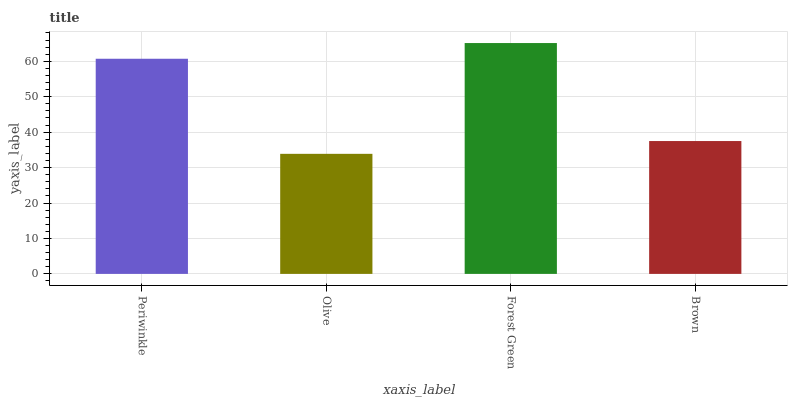Is Olive the minimum?
Answer yes or no. Yes. Is Forest Green the maximum?
Answer yes or no. Yes. Is Forest Green the minimum?
Answer yes or no. No. Is Olive the maximum?
Answer yes or no. No. Is Forest Green greater than Olive?
Answer yes or no. Yes. Is Olive less than Forest Green?
Answer yes or no. Yes. Is Olive greater than Forest Green?
Answer yes or no. No. Is Forest Green less than Olive?
Answer yes or no. No. Is Periwinkle the high median?
Answer yes or no. Yes. Is Brown the low median?
Answer yes or no. Yes. Is Forest Green the high median?
Answer yes or no. No. Is Olive the low median?
Answer yes or no. No. 